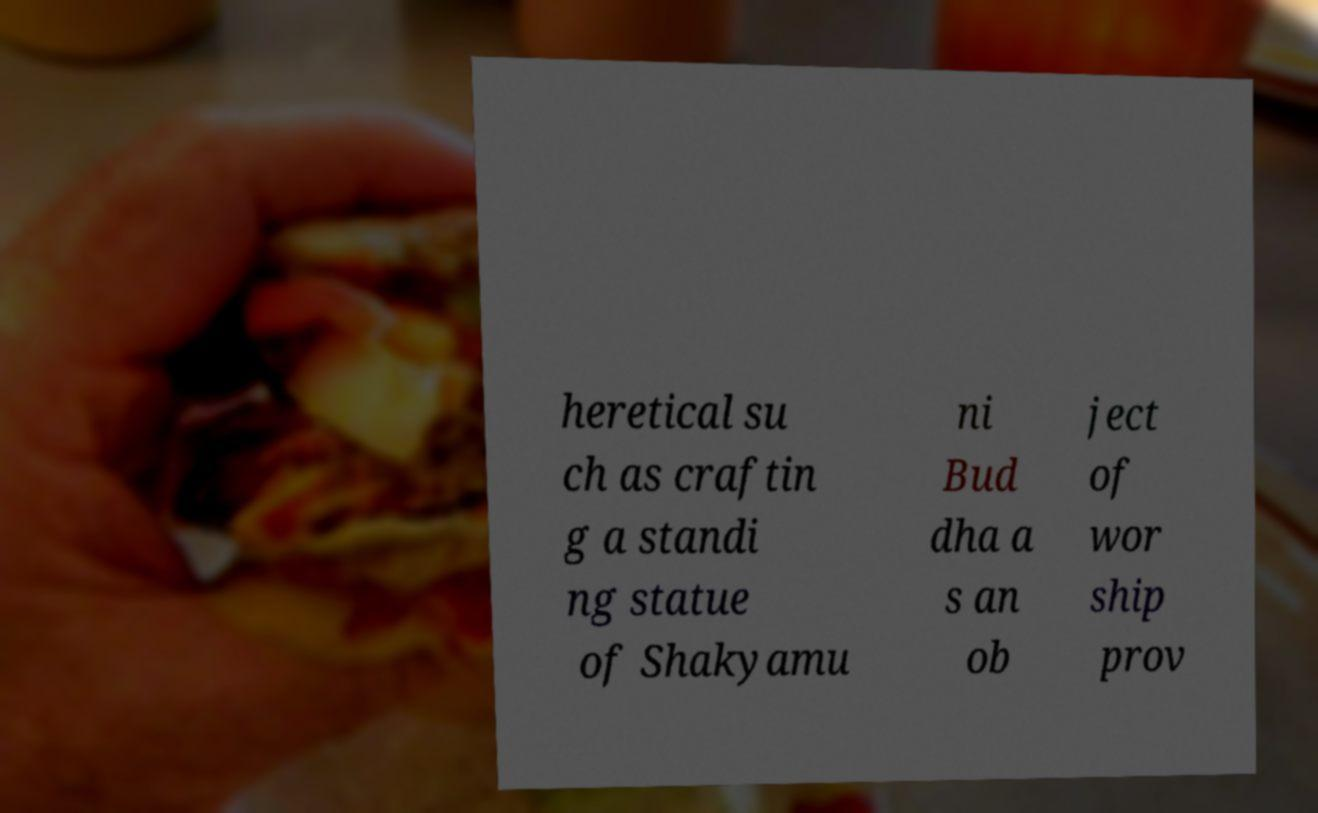Could you extract and type out the text from this image? heretical su ch as craftin g a standi ng statue of Shakyamu ni Bud dha a s an ob ject of wor ship prov 